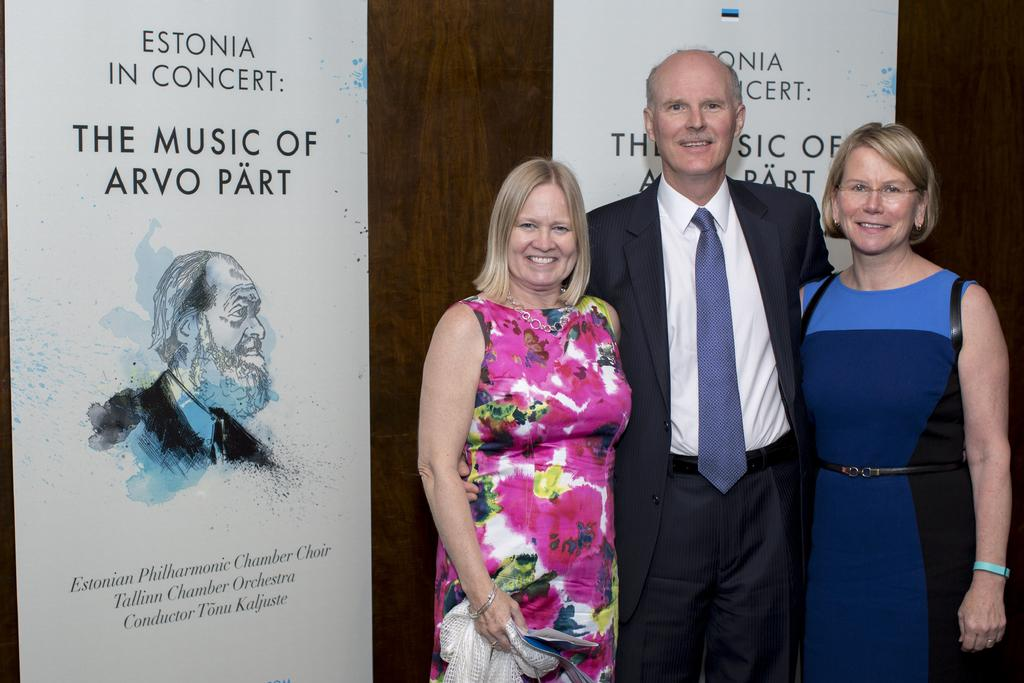Who is the main subject in the image? There is a man in the middle of the image. Are there any other people in the image? Yes, there are two women on either side of the man. What can be seen in the background of the image? There is a wall in the background of the image. What is on the wall in the background? There are posters on the wall. How many pizzas are being served on the table in the image? There is no table or pizzas present in the image. What type of vacation destination is shown in the image? The image does not depict a vacation destination; it features a man and two women with a wall and posters in the background. 